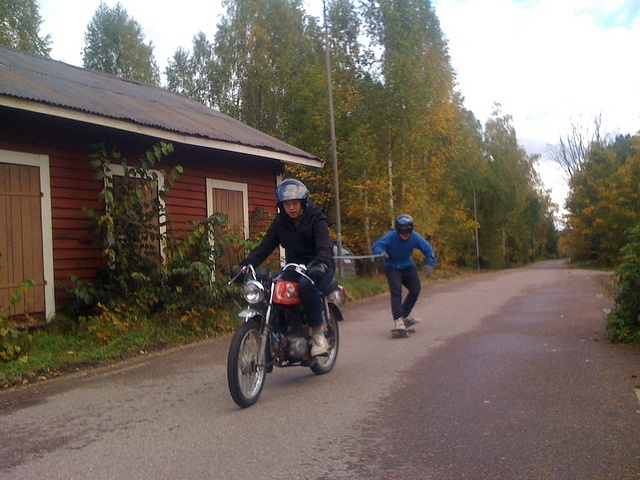Describe the objects in this image and their specific colors. I can see motorcycle in gray, black, darkgray, and maroon tones, people in gray, black, and darkgray tones, people in gray, black, navy, and blue tones, and skateboard in gray and black tones in this image. 